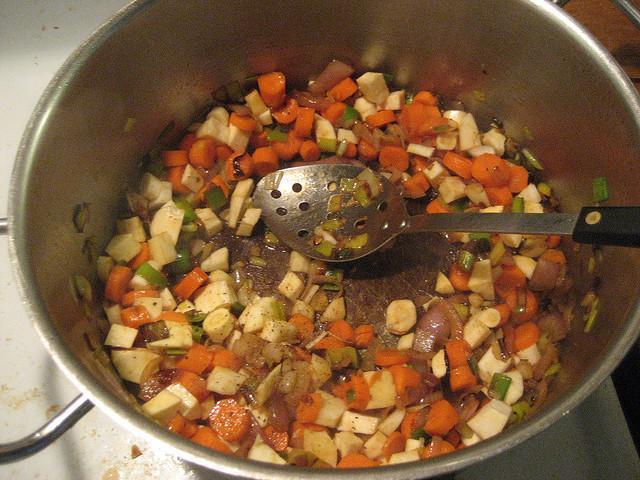How many carrots are in the picture?
Give a very brief answer. 2. 